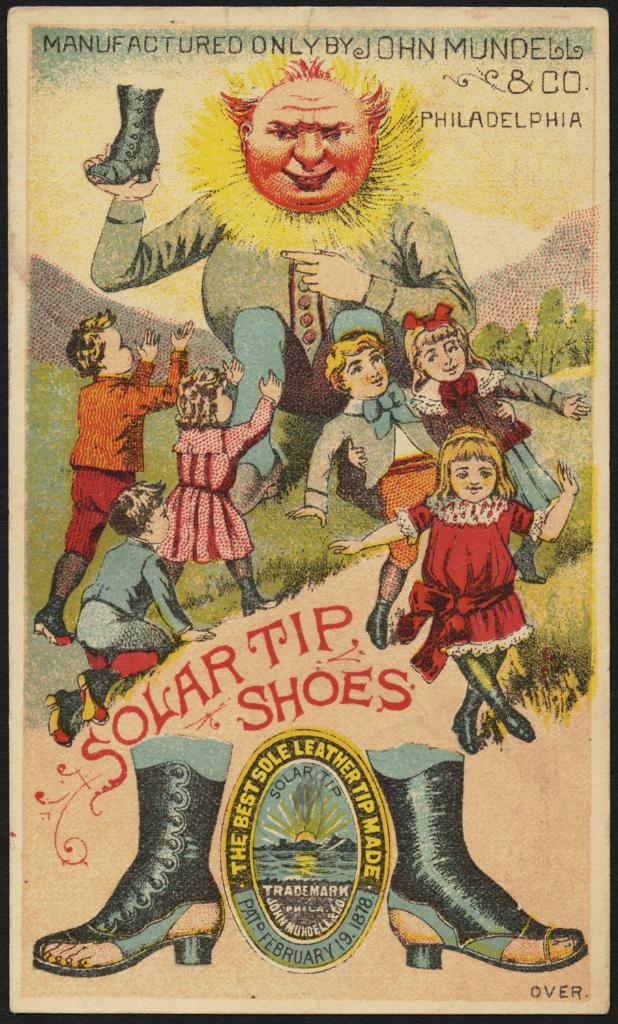What is the main subject of the image? There is a drawing in the image. What is being depicted in the drawing? The drawing depicts children and trees. What type of weather can be seen in the drawing? There is no weather depicted in the drawing; it only shows children and trees. Who is the mother of the children depicted in the drawing? There is no mother depicted in the drawing; it only shows children and trees. 